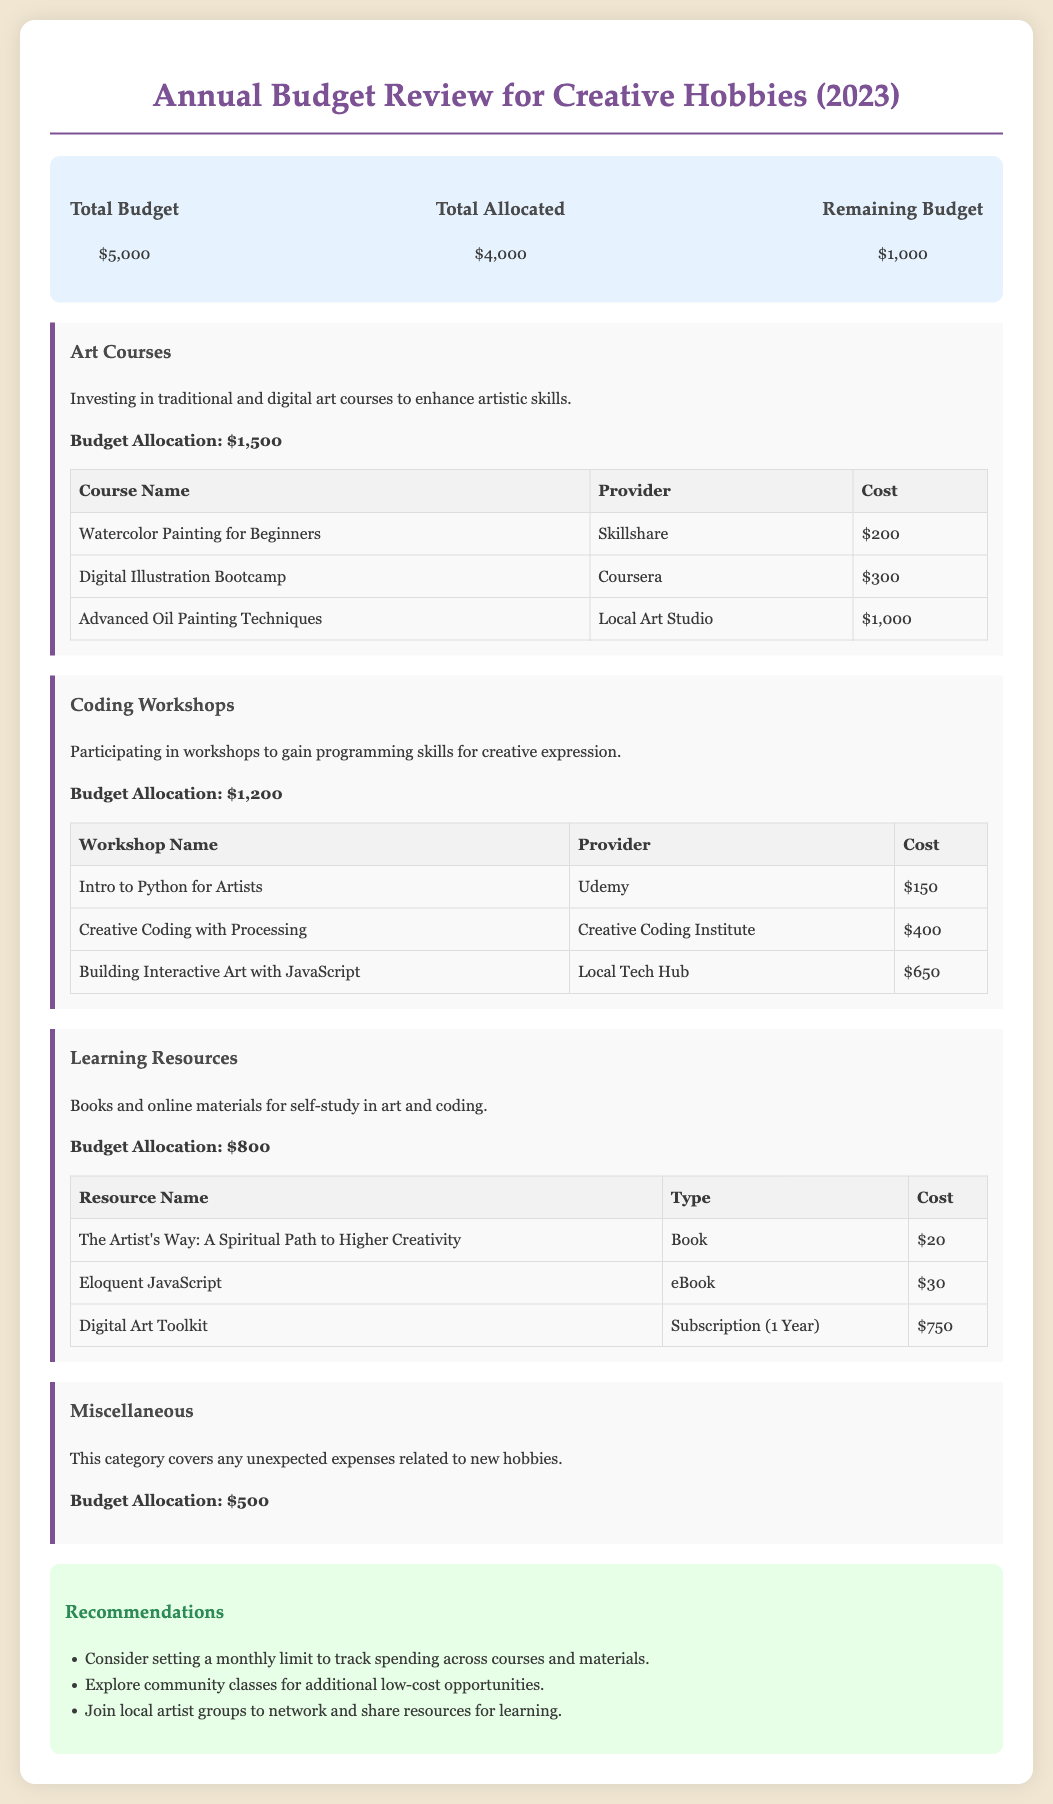What is the total budget? The total budget is stated in the document as the overall financial allocation for the year.
Answer: $5,000 What is the budget allocation for art courses? The document specifies the amount set aside for art courses to enhance artistic skills.
Answer: $1,500 How much is allocated for coding workshops? The document provides the specific funding designated for coding-related workshops.
Answer: $1,200 What is the cost of the Digital Art Toolkit? This resource’s cost is listed under learning resources in the document.
Answer: $750 Which provider offers the "Intro to Python for Artists" workshop? The document names the provider of this coding workshop within the budget section.
Answer: Udemy What is the remaining budget after allocations? The remaining budget can be calculated by subtracting the total allocated from the total budget.
Answer: $1,000 What is the total budget allocated? This number reflects how much of the total budget has been set aside for specific categories.
Answer: $4,000 How many recommendations are provided in the document? The recommendations section lists specific suggestions for managing expenses and resources.
Answer: Three What is the cost of the Advanced Oil Painting Techniques course? This cost is identified in the table under art courses in the budget review.
Answer: $1,000 